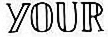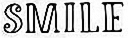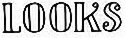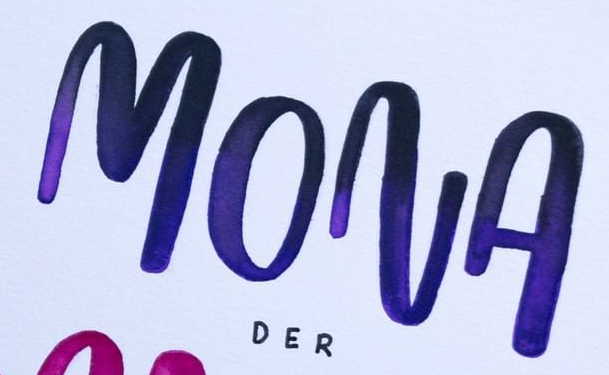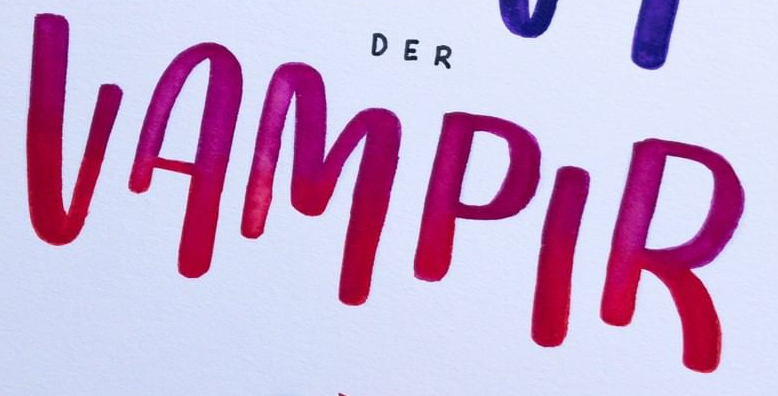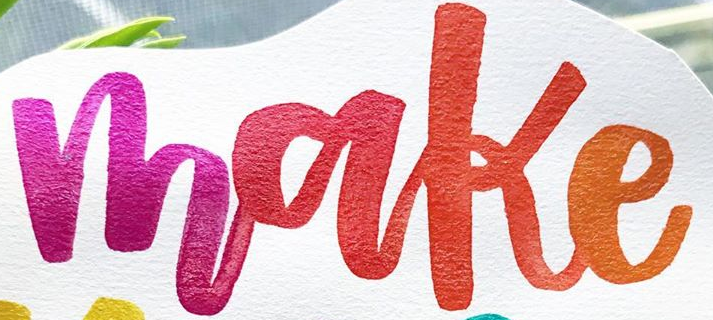What text is displayed in these images sequentially, separated by a semicolon? YOUR; SMILE; LOOKS; MONA; VAMPIR; make 